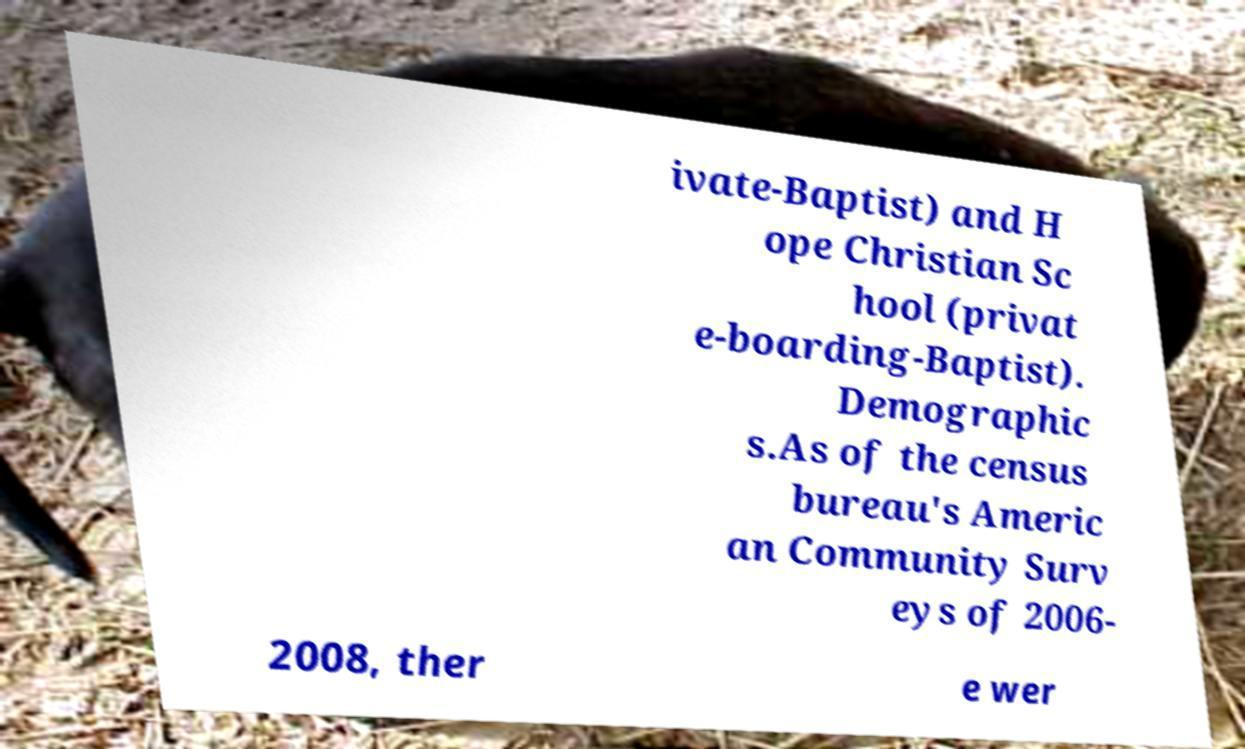Can you read and provide the text displayed in the image?This photo seems to have some interesting text. Can you extract and type it out for me? ivate-Baptist) and H ope Christian Sc hool (privat e-boarding-Baptist). Demographic s.As of the census bureau's Americ an Community Surv eys of 2006- 2008, ther e wer 